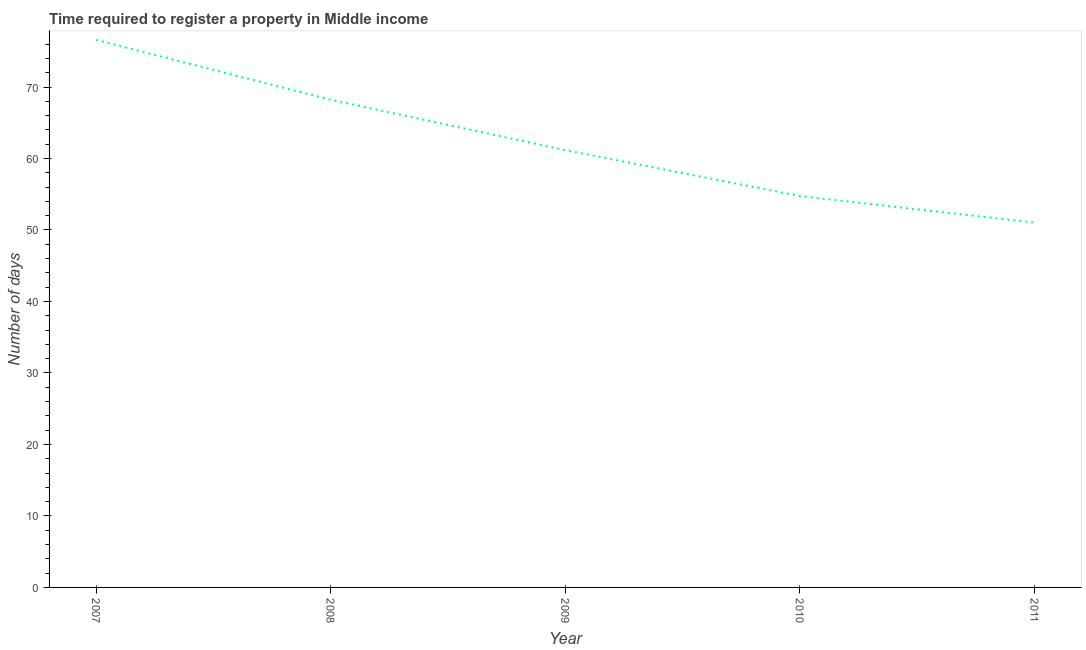What is the number of days required to register property in 2009?
Provide a succinct answer. 61.17. Across all years, what is the maximum number of days required to register property?
Offer a very short reply. 76.58. Across all years, what is the minimum number of days required to register property?
Your answer should be compact. 51.03. In which year was the number of days required to register property maximum?
Make the answer very short. 2007. In which year was the number of days required to register property minimum?
Make the answer very short. 2011. What is the sum of the number of days required to register property?
Provide a succinct answer. 311.74. What is the difference between the number of days required to register property in 2009 and 2011?
Give a very brief answer. 10.13. What is the average number of days required to register property per year?
Offer a very short reply. 62.35. What is the median number of days required to register property?
Provide a short and direct response. 61.17. What is the ratio of the number of days required to register property in 2009 to that in 2011?
Offer a very short reply. 1.2. What is the difference between the highest and the second highest number of days required to register property?
Provide a short and direct response. 8.37. What is the difference between the highest and the lowest number of days required to register property?
Your response must be concise. 25.55. In how many years, is the number of days required to register property greater than the average number of days required to register property taken over all years?
Your answer should be very brief. 2. Does the number of days required to register property monotonically increase over the years?
Ensure brevity in your answer.  No. How many lines are there?
Provide a short and direct response. 1. What is the difference between two consecutive major ticks on the Y-axis?
Your response must be concise. 10. Are the values on the major ticks of Y-axis written in scientific E-notation?
Your response must be concise. No. What is the title of the graph?
Your response must be concise. Time required to register a property in Middle income. What is the label or title of the Y-axis?
Give a very brief answer. Number of days. What is the Number of days of 2007?
Your answer should be very brief. 76.58. What is the Number of days of 2008?
Your answer should be very brief. 68.21. What is the Number of days in 2009?
Keep it short and to the point. 61.17. What is the Number of days of 2010?
Offer a very short reply. 54.74. What is the Number of days of 2011?
Give a very brief answer. 51.03. What is the difference between the Number of days in 2007 and 2008?
Give a very brief answer. 8.37. What is the difference between the Number of days in 2007 and 2009?
Provide a succinct answer. 15.41. What is the difference between the Number of days in 2007 and 2010?
Provide a succinct answer. 21.84. What is the difference between the Number of days in 2007 and 2011?
Offer a very short reply. 25.55. What is the difference between the Number of days in 2008 and 2009?
Make the answer very short. 7.04. What is the difference between the Number of days in 2008 and 2010?
Keep it short and to the point. 13.47. What is the difference between the Number of days in 2008 and 2011?
Provide a short and direct response. 17.18. What is the difference between the Number of days in 2009 and 2010?
Provide a succinct answer. 6.43. What is the difference between the Number of days in 2009 and 2011?
Your answer should be compact. 10.13. What is the difference between the Number of days in 2010 and 2011?
Your answer should be very brief. 3.71. What is the ratio of the Number of days in 2007 to that in 2008?
Make the answer very short. 1.12. What is the ratio of the Number of days in 2007 to that in 2009?
Offer a very short reply. 1.25. What is the ratio of the Number of days in 2007 to that in 2010?
Your answer should be very brief. 1.4. What is the ratio of the Number of days in 2007 to that in 2011?
Your response must be concise. 1.5. What is the ratio of the Number of days in 2008 to that in 2009?
Provide a succinct answer. 1.11. What is the ratio of the Number of days in 2008 to that in 2010?
Ensure brevity in your answer.  1.25. What is the ratio of the Number of days in 2008 to that in 2011?
Provide a short and direct response. 1.34. What is the ratio of the Number of days in 2009 to that in 2010?
Make the answer very short. 1.12. What is the ratio of the Number of days in 2009 to that in 2011?
Provide a succinct answer. 1.2. What is the ratio of the Number of days in 2010 to that in 2011?
Provide a short and direct response. 1.07. 